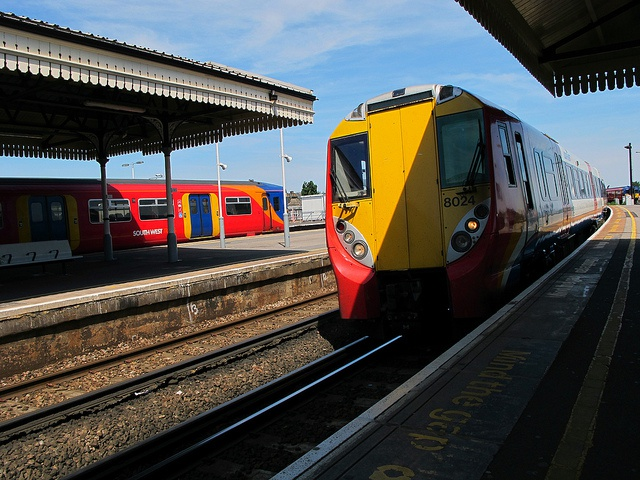Describe the objects in this image and their specific colors. I can see train in lightblue, black, orange, olive, and maroon tones and train in lightblue, black, red, gray, and orange tones in this image. 